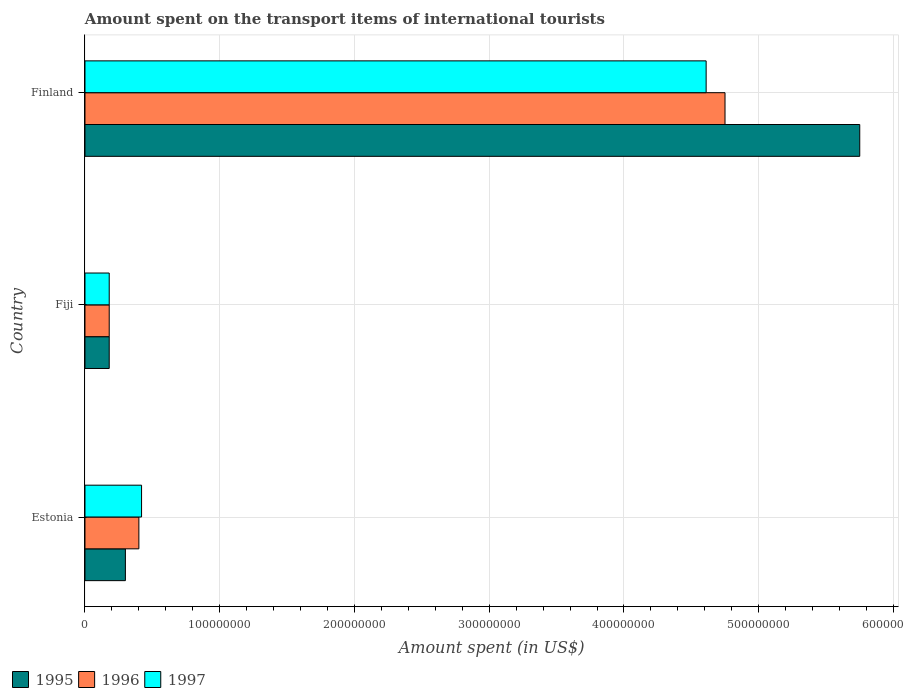Are the number of bars per tick equal to the number of legend labels?
Give a very brief answer. Yes. Are the number of bars on each tick of the Y-axis equal?
Your response must be concise. Yes. How many bars are there on the 2nd tick from the bottom?
Offer a terse response. 3. In how many cases, is the number of bars for a given country not equal to the number of legend labels?
Offer a terse response. 0. What is the amount spent on the transport items of international tourists in 1996 in Estonia?
Offer a very short reply. 4.00e+07. Across all countries, what is the maximum amount spent on the transport items of international tourists in 1996?
Keep it short and to the point. 4.75e+08. Across all countries, what is the minimum amount spent on the transport items of international tourists in 1995?
Your response must be concise. 1.80e+07. In which country was the amount spent on the transport items of international tourists in 1996 minimum?
Offer a very short reply. Fiji. What is the total amount spent on the transport items of international tourists in 1997 in the graph?
Give a very brief answer. 5.21e+08. What is the difference between the amount spent on the transport items of international tourists in 1997 in Estonia and that in Fiji?
Offer a very short reply. 2.40e+07. What is the difference between the amount spent on the transport items of international tourists in 1997 in Estonia and the amount spent on the transport items of international tourists in 1996 in Fiji?
Offer a very short reply. 2.40e+07. What is the average amount spent on the transport items of international tourists in 1995 per country?
Provide a succinct answer. 2.08e+08. What is the difference between the amount spent on the transport items of international tourists in 1997 and amount spent on the transport items of international tourists in 1995 in Fiji?
Keep it short and to the point. 0. In how many countries, is the amount spent on the transport items of international tourists in 1995 greater than 520000000 US$?
Provide a short and direct response. 1. What is the ratio of the amount spent on the transport items of international tourists in 1996 in Estonia to that in Finland?
Give a very brief answer. 0.08. Is the amount spent on the transport items of international tourists in 1996 in Estonia less than that in Finland?
Your answer should be very brief. Yes. What is the difference between the highest and the second highest amount spent on the transport items of international tourists in 1996?
Provide a short and direct response. 4.35e+08. What is the difference between the highest and the lowest amount spent on the transport items of international tourists in 1996?
Provide a short and direct response. 4.57e+08. In how many countries, is the amount spent on the transport items of international tourists in 1995 greater than the average amount spent on the transport items of international tourists in 1995 taken over all countries?
Your answer should be compact. 1. Is the sum of the amount spent on the transport items of international tourists in 1995 in Fiji and Finland greater than the maximum amount spent on the transport items of international tourists in 1996 across all countries?
Keep it short and to the point. Yes. What does the 2nd bar from the bottom in Finland represents?
Ensure brevity in your answer.  1996. How many bars are there?
Provide a short and direct response. 9. Are all the bars in the graph horizontal?
Offer a terse response. Yes. What is the difference between two consecutive major ticks on the X-axis?
Provide a succinct answer. 1.00e+08. Are the values on the major ticks of X-axis written in scientific E-notation?
Provide a succinct answer. No. Does the graph contain any zero values?
Give a very brief answer. No. How many legend labels are there?
Your response must be concise. 3. How are the legend labels stacked?
Give a very brief answer. Horizontal. What is the title of the graph?
Provide a short and direct response. Amount spent on the transport items of international tourists. Does "2014" appear as one of the legend labels in the graph?
Offer a very short reply. No. What is the label or title of the X-axis?
Your answer should be compact. Amount spent (in US$). What is the label or title of the Y-axis?
Make the answer very short. Country. What is the Amount spent (in US$) of 1995 in Estonia?
Make the answer very short. 3.00e+07. What is the Amount spent (in US$) in 1996 in Estonia?
Keep it short and to the point. 4.00e+07. What is the Amount spent (in US$) of 1997 in Estonia?
Provide a short and direct response. 4.20e+07. What is the Amount spent (in US$) of 1995 in Fiji?
Give a very brief answer. 1.80e+07. What is the Amount spent (in US$) in 1996 in Fiji?
Keep it short and to the point. 1.80e+07. What is the Amount spent (in US$) in 1997 in Fiji?
Your answer should be very brief. 1.80e+07. What is the Amount spent (in US$) in 1995 in Finland?
Provide a succinct answer. 5.75e+08. What is the Amount spent (in US$) in 1996 in Finland?
Offer a terse response. 4.75e+08. What is the Amount spent (in US$) of 1997 in Finland?
Offer a terse response. 4.61e+08. Across all countries, what is the maximum Amount spent (in US$) of 1995?
Your answer should be compact. 5.75e+08. Across all countries, what is the maximum Amount spent (in US$) in 1996?
Offer a very short reply. 4.75e+08. Across all countries, what is the maximum Amount spent (in US$) in 1997?
Your answer should be compact. 4.61e+08. Across all countries, what is the minimum Amount spent (in US$) in 1995?
Your answer should be compact. 1.80e+07. Across all countries, what is the minimum Amount spent (in US$) in 1996?
Provide a short and direct response. 1.80e+07. Across all countries, what is the minimum Amount spent (in US$) in 1997?
Your response must be concise. 1.80e+07. What is the total Amount spent (in US$) of 1995 in the graph?
Your answer should be very brief. 6.23e+08. What is the total Amount spent (in US$) in 1996 in the graph?
Ensure brevity in your answer.  5.33e+08. What is the total Amount spent (in US$) of 1997 in the graph?
Provide a succinct answer. 5.21e+08. What is the difference between the Amount spent (in US$) of 1995 in Estonia and that in Fiji?
Give a very brief answer. 1.20e+07. What is the difference between the Amount spent (in US$) of 1996 in Estonia and that in Fiji?
Keep it short and to the point. 2.20e+07. What is the difference between the Amount spent (in US$) of 1997 in Estonia and that in Fiji?
Make the answer very short. 2.40e+07. What is the difference between the Amount spent (in US$) in 1995 in Estonia and that in Finland?
Give a very brief answer. -5.45e+08. What is the difference between the Amount spent (in US$) in 1996 in Estonia and that in Finland?
Your response must be concise. -4.35e+08. What is the difference between the Amount spent (in US$) in 1997 in Estonia and that in Finland?
Keep it short and to the point. -4.19e+08. What is the difference between the Amount spent (in US$) in 1995 in Fiji and that in Finland?
Make the answer very short. -5.57e+08. What is the difference between the Amount spent (in US$) in 1996 in Fiji and that in Finland?
Give a very brief answer. -4.57e+08. What is the difference between the Amount spent (in US$) of 1997 in Fiji and that in Finland?
Offer a very short reply. -4.43e+08. What is the difference between the Amount spent (in US$) in 1996 in Estonia and the Amount spent (in US$) in 1997 in Fiji?
Give a very brief answer. 2.20e+07. What is the difference between the Amount spent (in US$) of 1995 in Estonia and the Amount spent (in US$) of 1996 in Finland?
Offer a very short reply. -4.45e+08. What is the difference between the Amount spent (in US$) in 1995 in Estonia and the Amount spent (in US$) in 1997 in Finland?
Your answer should be compact. -4.31e+08. What is the difference between the Amount spent (in US$) of 1996 in Estonia and the Amount spent (in US$) of 1997 in Finland?
Ensure brevity in your answer.  -4.21e+08. What is the difference between the Amount spent (in US$) in 1995 in Fiji and the Amount spent (in US$) in 1996 in Finland?
Make the answer very short. -4.57e+08. What is the difference between the Amount spent (in US$) of 1995 in Fiji and the Amount spent (in US$) of 1997 in Finland?
Offer a very short reply. -4.43e+08. What is the difference between the Amount spent (in US$) of 1996 in Fiji and the Amount spent (in US$) of 1997 in Finland?
Provide a short and direct response. -4.43e+08. What is the average Amount spent (in US$) in 1995 per country?
Provide a short and direct response. 2.08e+08. What is the average Amount spent (in US$) in 1996 per country?
Provide a short and direct response. 1.78e+08. What is the average Amount spent (in US$) in 1997 per country?
Offer a terse response. 1.74e+08. What is the difference between the Amount spent (in US$) of 1995 and Amount spent (in US$) of 1996 in Estonia?
Your answer should be very brief. -1.00e+07. What is the difference between the Amount spent (in US$) of 1995 and Amount spent (in US$) of 1997 in Estonia?
Give a very brief answer. -1.20e+07. What is the difference between the Amount spent (in US$) of 1995 and Amount spent (in US$) of 1997 in Fiji?
Your answer should be very brief. 0. What is the difference between the Amount spent (in US$) of 1995 and Amount spent (in US$) of 1997 in Finland?
Give a very brief answer. 1.14e+08. What is the difference between the Amount spent (in US$) in 1996 and Amount spent (in US$) in 1997 in Finland?
Offer a terse response. 1.40e+07. What is the ratio of the Amount spent (in US$) of 1996 in Estonia to that in Fiji?
Ensure brevity in your answer.  2.22. What is the ratio of the Amount spent (in US$) of 1997 in Estonia to that in Fiji?
Your answer should be very brief. 2.33. What is the ratio of the Amount spent (in US$) in 1995 in Estonia to that in Finland?
Provide a short and direct response. 0.05. What is the ratio of the Amount spent (in US$) of 1996 in Estonia to that in Finland?
Give a very brief answer. 0.08. What is the ratio of the Amount spent (in US$) of 1997 in Estonia to that in Finland?
Your response must be concise. 0.09. What is the ratio of the Amount spent (in US$) of 1995 in Fiji to that in Finland?
Keep it short and to the point. 0.03. What is the ratio of the Amount spent (in US$) in 1996 in Fiji to that in Finland?
Make the answer very short. 0.04. What is the ratio of the Amount spent (in US$) of 1997 in Fiji to that in Finland?
Provide a succinct answer. 0.04. What is the difference between the highest and the second highest Amount spent (in US$) in 1995?
Your answer should be very brief. 5.45e+08. What is the difference between the highest and the second highest Amount spent (in US$) in 1996?
Your answer should be compact. 4.35e+08. What is the difference between the highest and the second highest Amount spent (in US$) in 1997?
Provide a succinct answer. 4.19e+08. What is the difference between the highest and the lowest Amount spent (in US$) of 1995?
Your answer should be compact. 5.57e+08. What is the difference between the highest and the lowest Amount spent (in US$) of 1996?
Your answer should be very brief. 4.57e+08. What is the difference between the highest and the lowest Amount spent (in US$) in 1997?
Make the answer very short. 4.43e+08. 